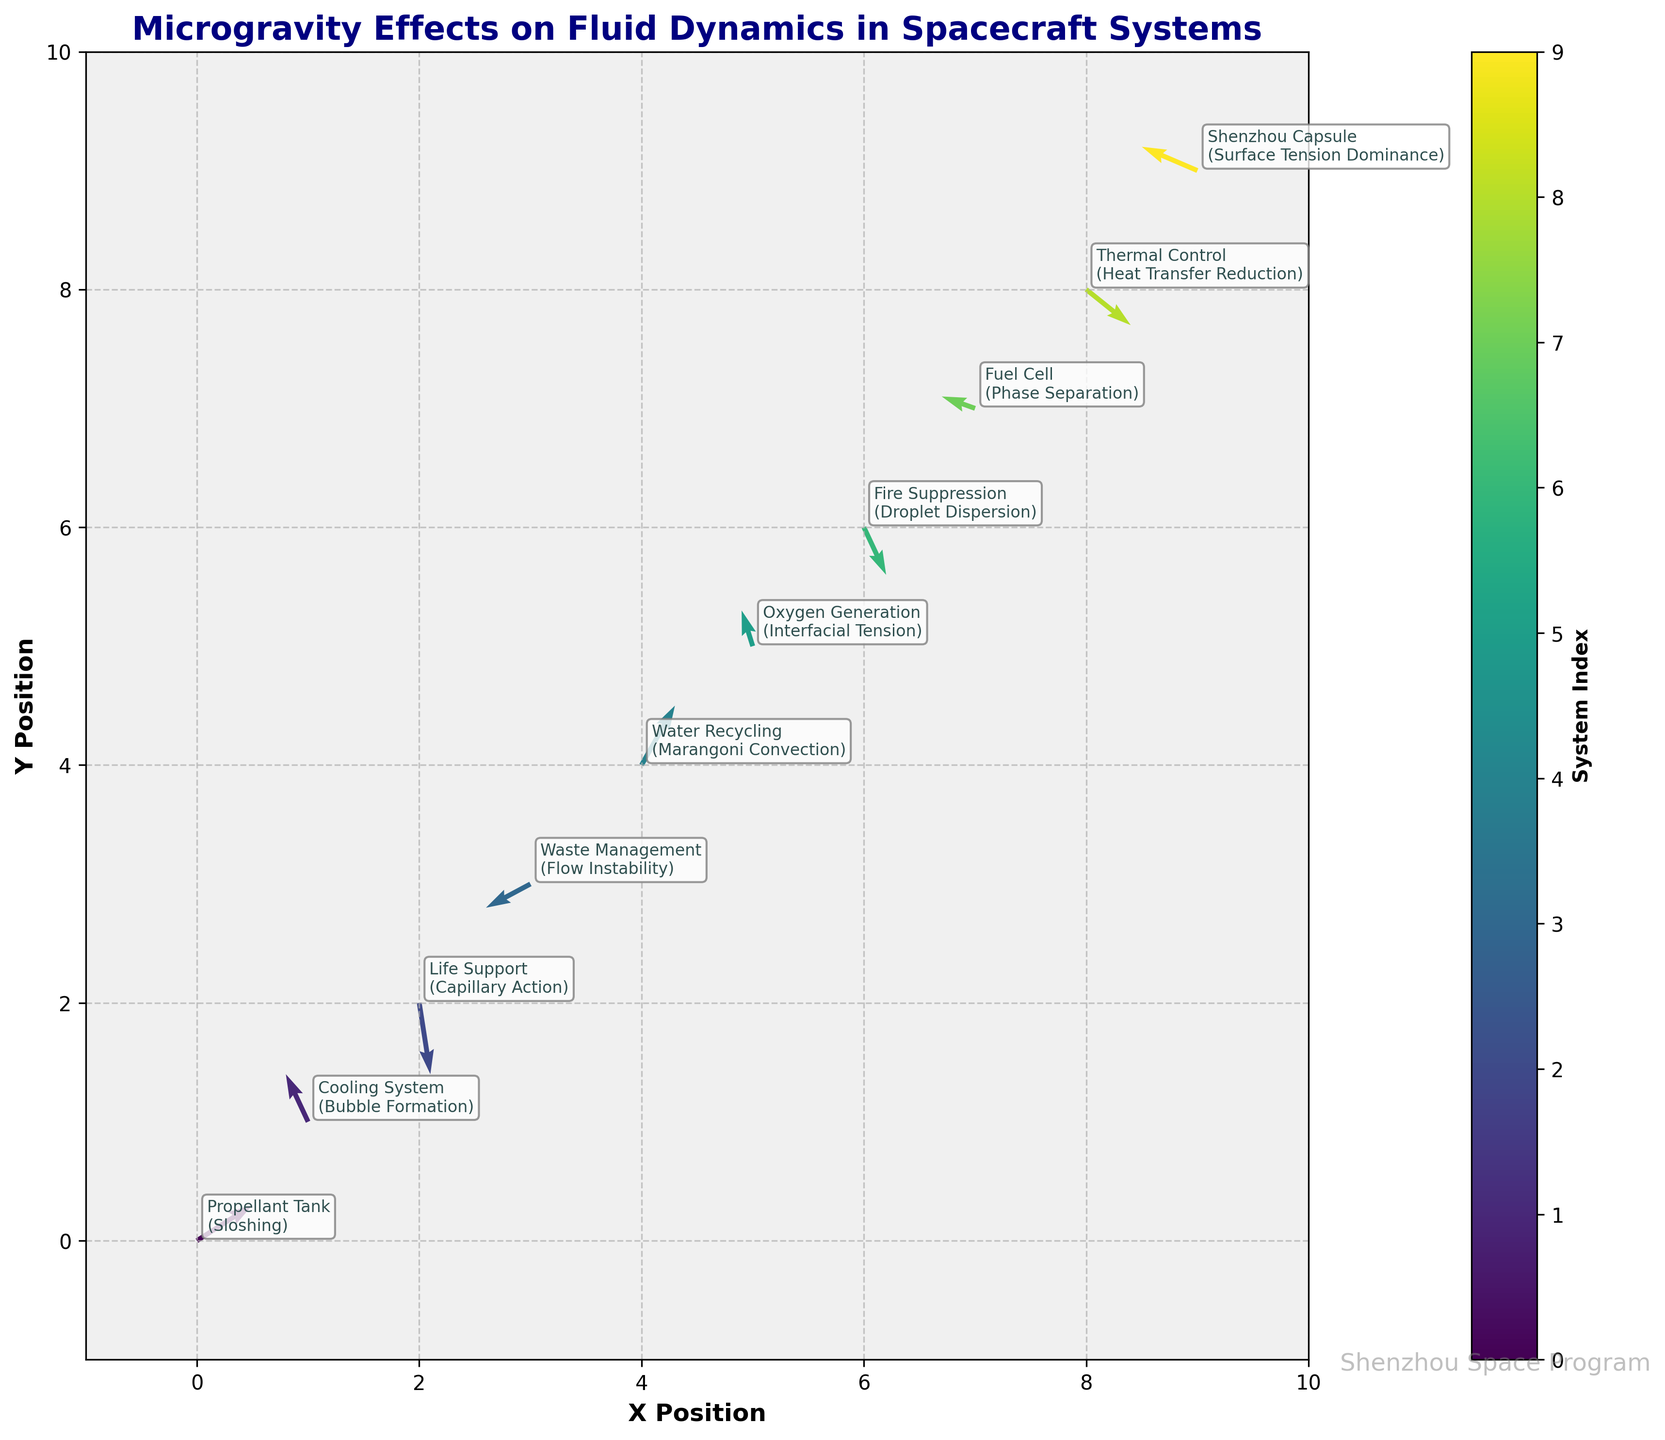How many data points representing different systems are shown in the plot? To determine the number of data points, we count the number of arrows present in the figure. Each arrow corresponds to a different system.
Answer: 10 What system is represented at the position (4,4) and what effect does it encounter? We look at the labels at the specified position (4, 4). It shows "Water Recycling" and the effect mentioned is "Marangoni Convection."
Answer: Water Recycling, Marangoni Convection Which system shows the strongest upward flow? To find the strongest upward flow, we need to look for the arrow with the highest positive V-component. The highest V-component is at (4, 4) for the "Water Recycling" system with V = 0.5.
Answer: Water Recycling What is the impact on the life support system depicted in the plot? To determine the impact on the life support system, we locate where it's labeled in the figure. At position (2, 2), the effect is noted as "Capillary Action."
Answer: Capillary Action Compare the flow direction of the propellant tank system and the Shenzhou capsule. First, we identify that the propellant tank is at (0, 0) with a direction indicated by the vector (0.5, 0.3). The Shenzhou capsule is at (9, 9) with a vector (-0.5, 0.2). The propellant tank has a positive x and y direction, while the Shenzhou capsule has a negative x and positive y direction.
Answer: Propellant Tank: Positive X and Y; Shenzhou Capsule: Negative X and Positive Y Which system has the lowest V-component (most downward flow)? We look for the vector with the most negative V-component in the figure. The lowest V-component is -0.6 for "Life Support" at position (2, 2).
Answer: Life Support Where is the phase separation phenomenon occurring according to the figure? We locate where "Phase Separation" is labeled in the plot. It is at position (7, 7) for the "Fuel Cell" system.
Answer: Fuel Cell How does the direction of flow in the cooling system compare to the waste management system? We compare the vectors at the corresponding positions. The cooling system at (1, 1) has a vector of (-0.2, 0.4) indicating a leftward and upward flow. The waste management system at (3, 3) has a vector of (-0.4, -0.2) indicating a leftward and downward flow.
Answer: Cooling System: Leftward and Upward; Waste Management: Leftward and Downward What is the main focus indicated by the figure title? The title of the figure indicates the main focus, which is "Microgravity Effects on Fluid Dynamics in Spacecraft Systems."
Answer: Microgravity Effects on Fluid Dynamics Which system has an effect of droplet dispersion, and what is its directional flow vector? We locate the system label with "Droplet Dispersion," found at position (6, 6). The directional flow vector for this system is (0.2, -0.4).
Answer: Fire Suppression, (0.2, -0.4) 